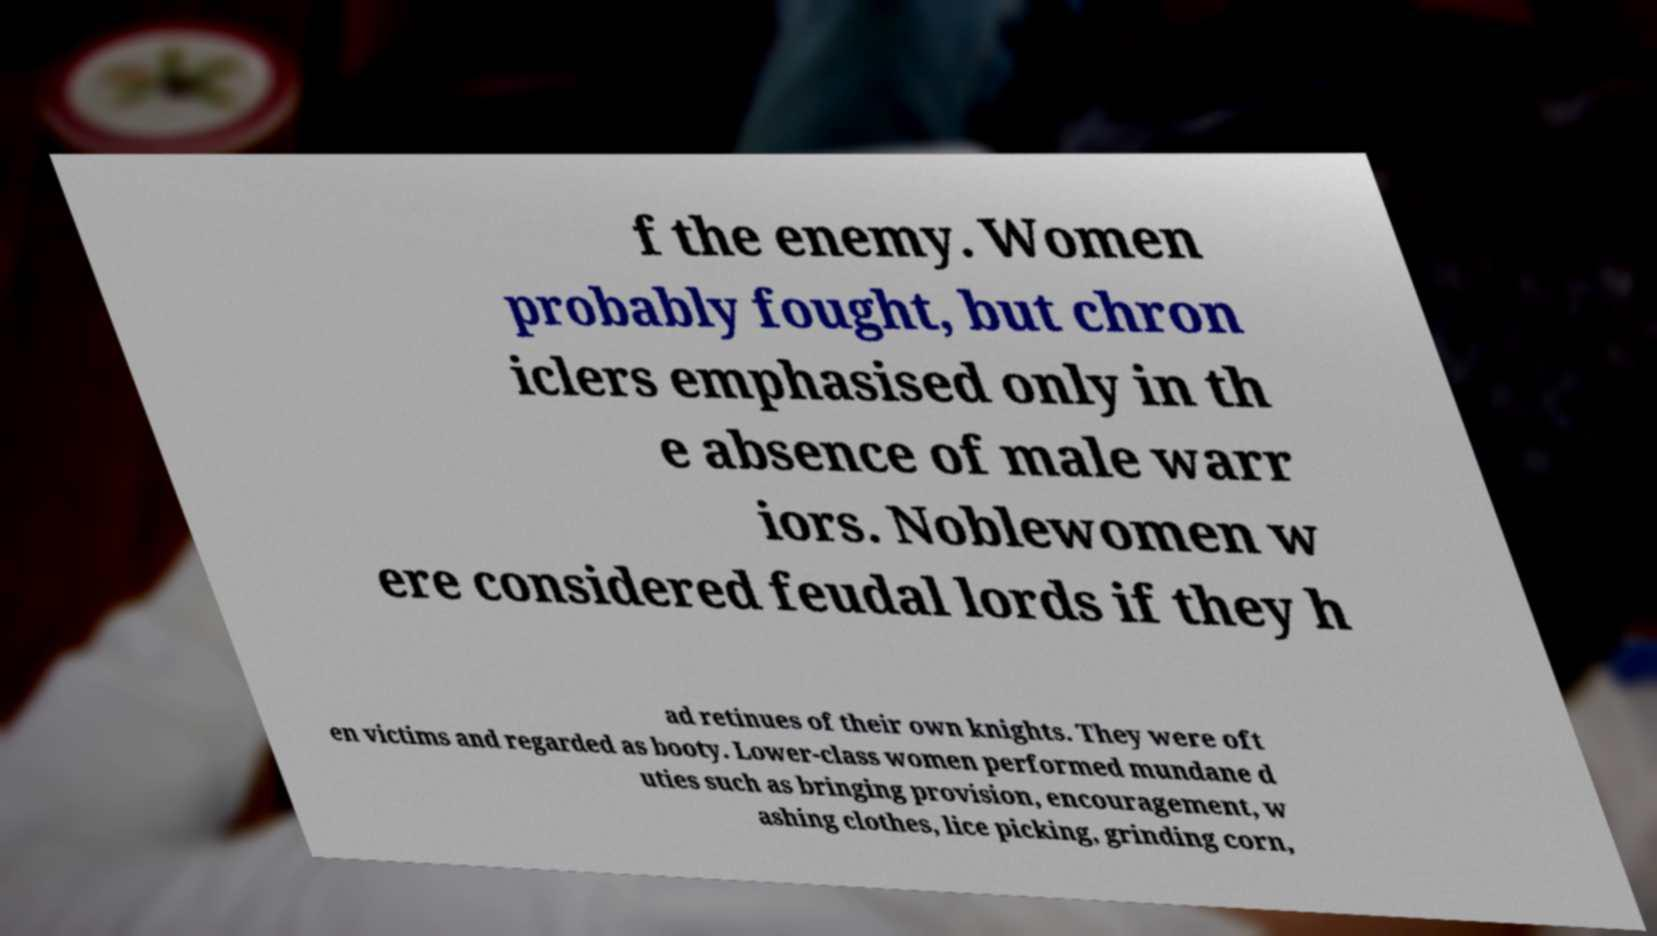Can you accurately transcribe the text from the provided image for me? f the enemy. Women probably fought, but chron iclers emphasised only in th e absence of male warr iors. Noblewomen w ere considered feudal lords if they h ad retinues of their own knights. They were oft en victims and regarded as booty. Lower-class women performed mundane d uties such as bringing provision, encouragement, w ashing clothes, lice picking, grinding corn, 